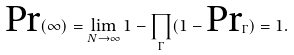<formula> <loc_0><loc_0><loc_500><loc_500>\text {Pr} ( \infty ) = \lim _ { N \rightarrow \infty } 1 - \prod _ { \Gamma } ( 1 - \text {Pr} _ { \Gamma } ) = 1 .</formula> 